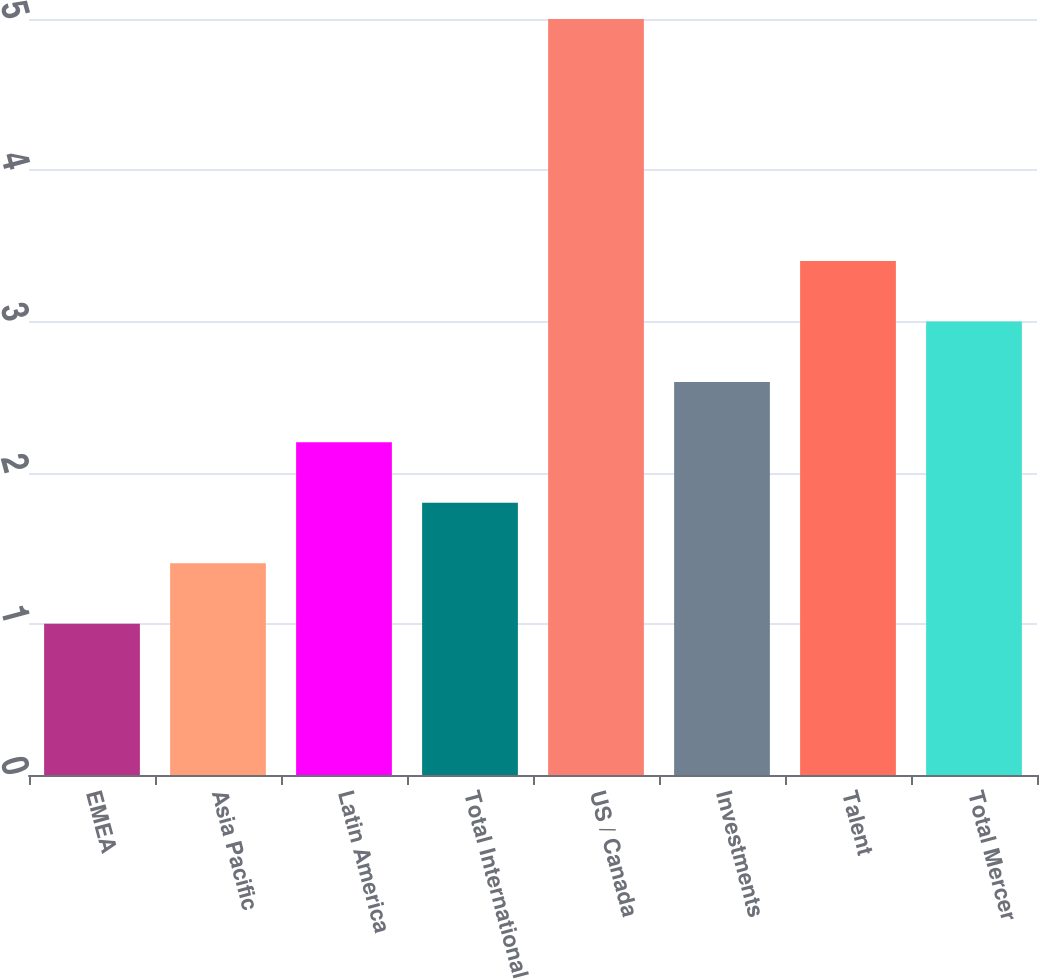Convert chart to OTSL. <chart><loc_0><loc_0><loc_500><loc_500><bar_chart><fcel>EMEA<fcel>Asia Pacific<fcel>Latin America<fcel>Total International<fcel>US / Canada<fcel>Investments<fcel>Talent<fcel>Total Mercer<nl><fcel>1<fcel>1.4<fcel>2.2<fcel>1.8<fcel>5<fcel>2.6<fcel>3.4<fcel>3<nl></chart> 